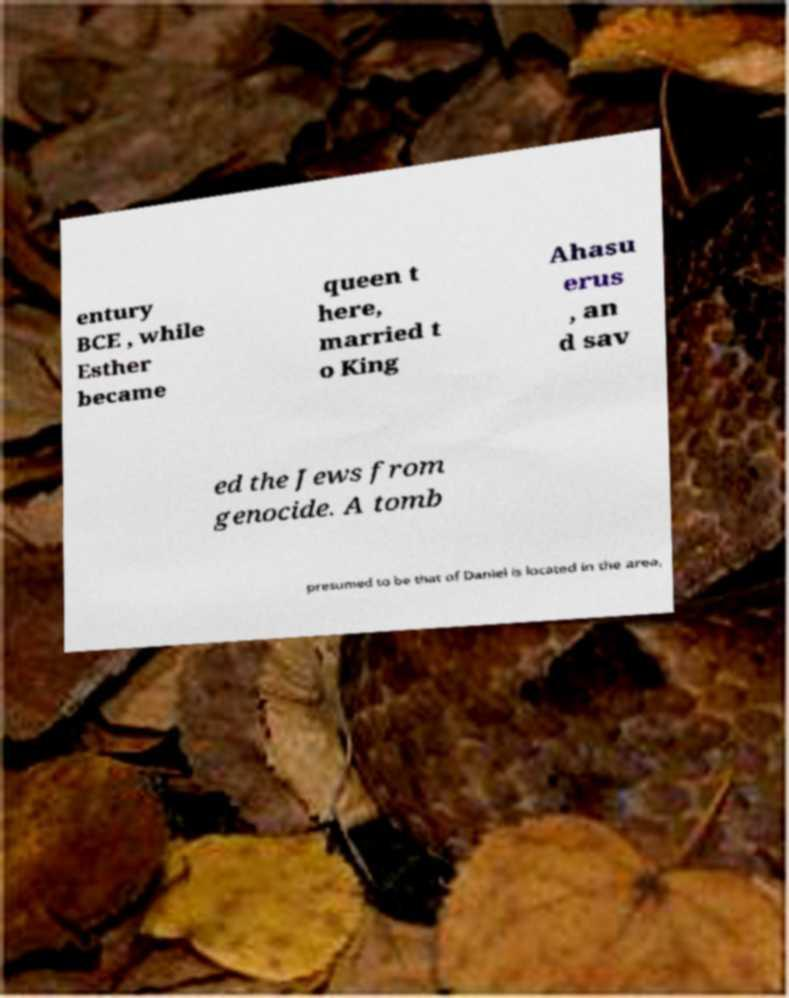What messages or text are displayed in this image? I need them in a readable, typed format. entury BCE , while Esther became queen t here, married t o King Ahasu erus , an d sav ed the Jews from genocide. A tomb presumed to be that of Daniel is located in the area, 